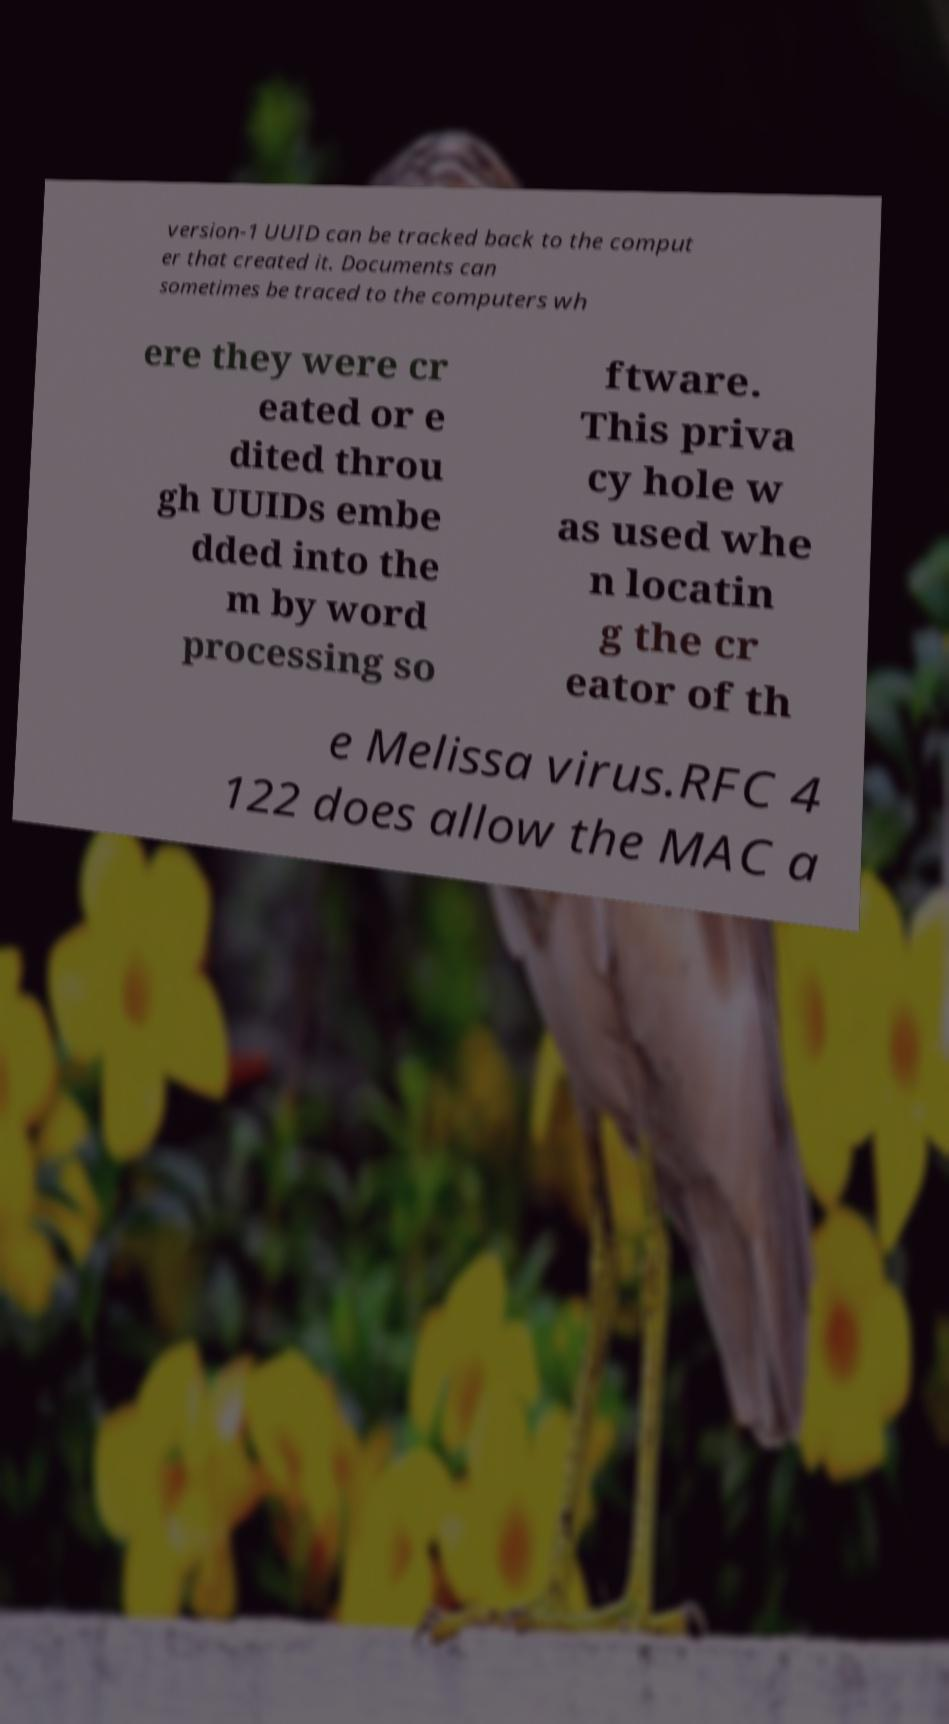I need the written content from this picture converted into text. Can you do that? version-1 UUID can be tracked back to the comput er that created it. Documents can sometimes be traced to the computers wh ere they were cr eated or e dited throu gh UUIDs embe dded into the m by word processing so ftware. This priva cy hole w as used whe n locatin g the cr eator of th e Melissa virus.RFC 4 122 does allow the MAC a 